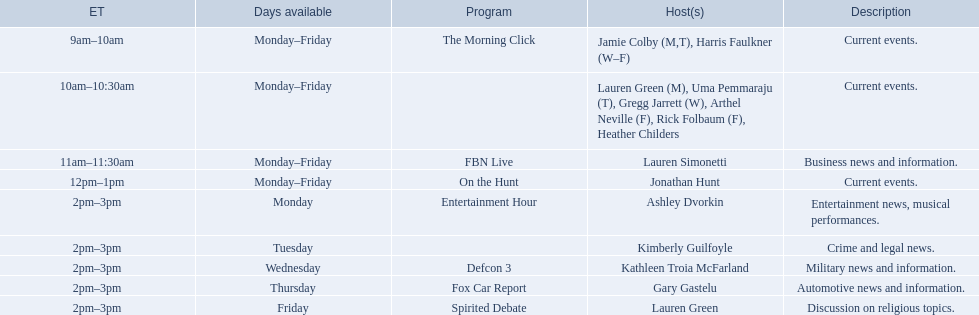What programs showcased by fox news channel anchors are itemized? Jamie Colby (M,T), Harris Faulkner (W–F), Lauren Green (M), Uma Pemmaraju (T), Gregg Jarrett (W), Arthel Neville (F), Rick Folbaum (F), Heather Childers, Lauren Simonetti, Jonathan Hunt, Ashley Dvorkin, Kimberly Guilfoyle, Kathleen Troia McFarland, Gary Gastelu, Lauren Green. From those, who have broadcasts on friday? Jamie Colby (M,T), Harris Faulkner (W–F), Lauren Green (M), Uma Pemmaraju (T), Gregg Jarrett (W), Arthel Neville (F), Rick Folbaum (F), Heather Childers, Lauren Simonetti, Jonathan Hunt, Lauren Green. Out of those, whose takes place at 2 pm? Lauren Green. Can you list all the hosts? Jamie Colby (M,T), Harris Faulkner (W–F), Lauren Green (M), Uma Pemmaraju (T), Gregg Jarrett (W), Arthel Neville (F), Rick Folbaum (F), Heather Childers, Lauren Simonetti, Jonathan Hunt, Ashley Dvorkin, Kimberly Guilfoyle, Kathleen Troia McFarland, Gary Gastelu, Lauren Green. Which ones have shows scheduled on fridays? Jamie Colby (M,T), Harris Faulkner (W–F), Lauren Green (M), Uma Pemmaraju (T), Gregg Jarrett (W), Arthel Neville (F), Rick Folbaum (F), Heather Childers, Lauren Simonetti, Jonathan Hunt, Lauren Green. Out of those, who has their show airing at 2pm? Lauren Green. Who are the various hosts? Jamie Colby (M,T), Harris Faulkner (W–F), Lauren Green (M), Uma Pemmaraju (T), Gregg Jarrett (W), Arthel Neville (F), Rick Folbaum (F), Heather Childers, Lauren Simonetti, Jonathan Hunt, Ashley Dvorkin, Kimberly Guilfoyle, Kathleen Troia McFarland, Gary Gastelu, Lauren Green. Which hosts feature shows on friday? Jamie Colby (M,T), Harris Faulkner (W–F), Lauren Green (M), Uma Pemmaraju (T), Gregg Jarrett (W), Arthel Neville (F), Rick Folbaum (F), Heather Childers, Lauren Simonetti, Jonathan Hunt, Lauren Green. From those, which host's program is shown at 2pm? Lauren Green. 